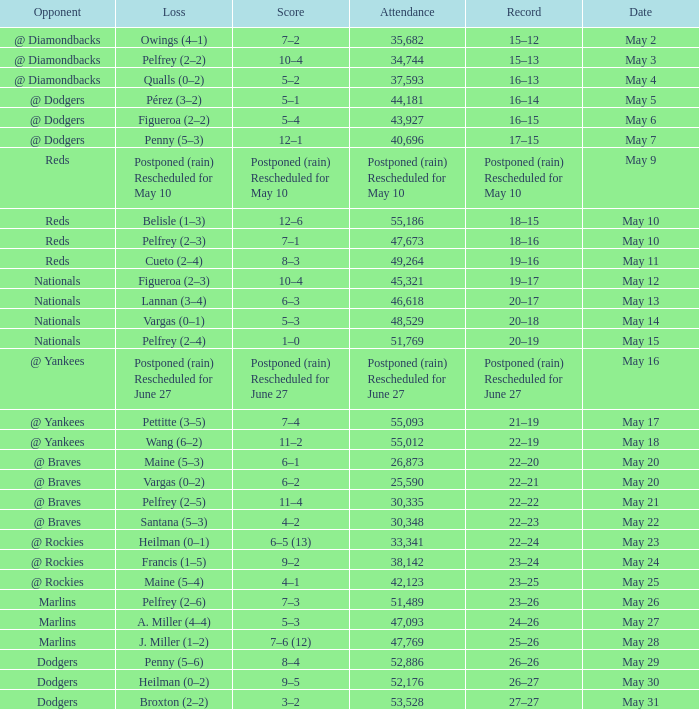Opponent of @ braves, and a Loss of pelfrey (2–5) had what score? 11–4. 